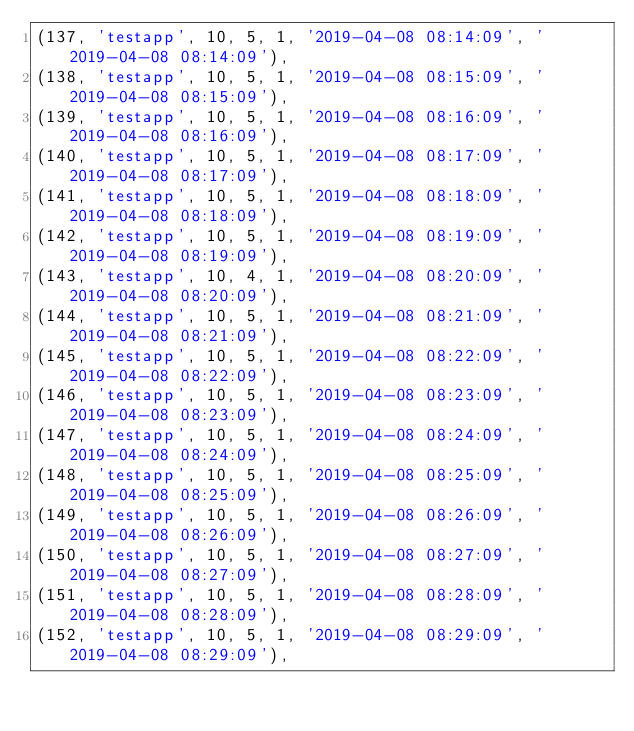<code> <loc_0><loc_0><loc_500><loc_500><_SQL_>(137, 'testapp', 10, 5, 1, '2019-04-08 08:14:09', '2019-04-08 08:14:09'),
(138, 'testapp', 10, 5, 1, '2019-04-08 08:15:09', '2019-04-08 08:15:09'),
(139, 'testapp', 10, 5, 1, '2019-04-08 08:16:09', '2019-04-08 08:16:09'),
(140, 'testapp', 10, 5, 1, '2019-04-08 08:17:09', '2019-04-08 08:17:09'),
(141, 'testapp', 10, 5, 1, '2019-04-08 08:18:09', '2019-04-08 08:18:09'),
(142, 'testapp', 10, 5, 1, '2019-04-08 08:19:09', '2019-04-08 08:19:09'),
(143, 'testapp', 10, 4, 1, '2019-04-08 08:20:09', '2019-04-08 08:20:09'),
(144, 'testapp', 10, 5, 1, '2019-04-08 08:21:09', '2019-04-08 08:21:09'),
(145, 'testapp', 10, 5, 1, '2019-04-08 08:22:09', '2019-04-08 08:22:09'),
(146, 'testapp', 10, 5, 1, '2019-04-08 08:23:09', '2019-04-08 08:23:09'),
(147, 'testapp', 10, 5, 1, '2019-04-08 08:24:09', '2019-04-08 08:24:09'),
(148, 'testapp', 10, 5, 1, '2019-04-08 08:25:09', '2019-04-08 08:25:09'),
(149, 'testapp', 10, 5, 1, '2019-04-08 08:26:09', '2019-04-08 08:26:09'),
(150, 'testapp', 10, 5, 1, '2019-04-08 08:27:09', '2019-04-08 08:27:09'),
(151, 'testapp', 10, 5, 1, '2019-04-08 08:28:09', '2019-04-08 08:28:09'),
(152, 'testapp', 10, 5, 1, '2019-04-08 08:29:09', '2019-04-08 08:29:09'),</code> 